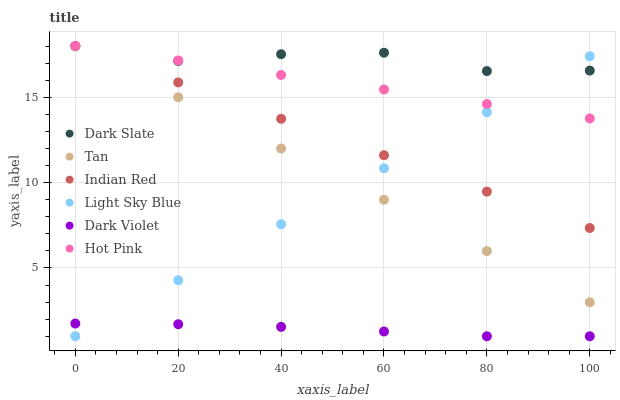Does Dark Violet have the minimum area under the curve?
Answer yes or no. Yes. Does Dark Slate have the maximum area under the curve?
Answer yes or no. Yes. Does Dark Slate have the minimum area under the curve?
Answer yes or no. No. Does Dark Violet have the maximum area under the curve?
Answer yes or no. No. Is Tan the smoothest?
Answer yes or no. Yes. Is Dark Slate the roughest?
Answer yes or no. Yes. Is Dark Violet the smoothest?
Answer yes or no. No. Is Dark Violet the roughest?
Answer yes or no. No. Does Dark Violet have the lowest value?
Answer yes or no. Yes. Does Dark Slate have the lowest value?
Answer yes or no. No. Does Tan have the highest value?
Answer yes or no. Yes. Does Dark Violet have the highest value?
Answer yes or no. No. Is Dark Violet less than Indian Red?
Answer yes or no. Yes. Is Hot Pink greater than Dark Violet?
Answer yes or no. Yes. Does Hot Pink intersect Indian Red?
Answer yes or no. Yes. Is Hot Pink less than Indian Red?
Answer yes or no. No. Is Hot Pink greater than Indian Red?
Answer yes or no. No. Does Dark Violet intersect Indian Red?
Answer yes or no. No. 